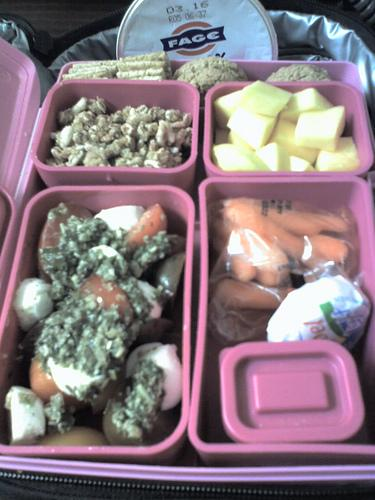What does the company whose logo appears at the top specialize in?

Choices:
A) yogurt
B) pizza
C) hot dogs
D) broccoli yogurt 